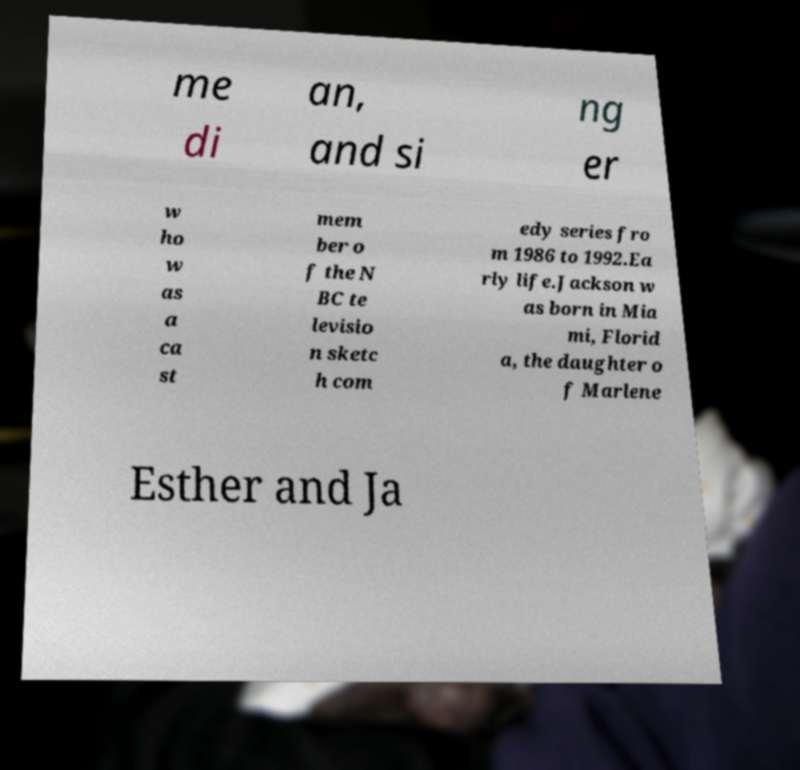There's text embedded in this image that I need extracted. Can you transcribe it verbatim? me di an, and si ng er w ho w as a ca st mem ber o f the N BC te levisio n sketc h com edy series fro m 1986 to 1992.Ea rly life.Jackson w as born in Mia mi, Florid a, the daughter o f Marlene Esther and Ja 